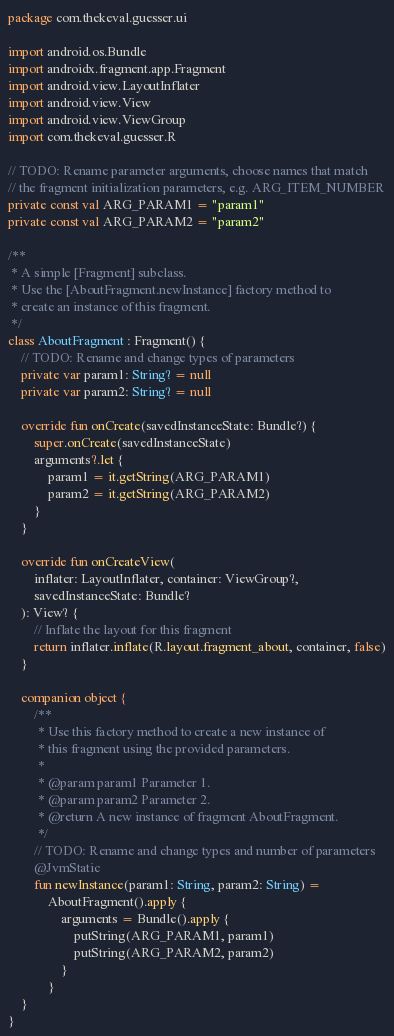Convert code to text. <code><loc_0><loc_0><loc_500><loc_500><_Kotlin_>package com.thekeval.guesser.ui

import android.os.Bundle
import androidx.fragment.app.Fragment
import android.view.LayoutInflater
import android.view.View
import android.view.ViewGroup
import com.thekeval.guesser.R

// TODO: Rename parameter arguments, choose names that match
// the fragment initialization parameters, e.g. ARG_ITEM_NUMBER
private const val ARG_PARAM1 = "param1"
private const val ARG_PARAM2 = "param2"

/**
 * A simple [Fragment] subclass.
 * Use the [AboutFragment.newInstance] factory method to
 * create an instance of this fragment.
 */
class AboutFragment : Fragment() {
    // TODO: Rename and change types of parameters
    private var param1: String? = null
    private var param2: String? = null

    override fun onCreate(savedInstanceState: Bundle?) {
        super.onCreate(savedInstanceState)
        arguments?.let {
            param1 = it.getString(ARG_PARAM1)
            param2 = it.getString(ARG_PARAM2)
        }
    }

    override fun onCreateView(
        inflater: LayoutInflater, container: ViewGroup?,
        savedInstanceState: Bundle?
    ): View? {
        // Inflate the layout for this fragment
        return inflater.inflate(R.layout.fragment_about, container, false)
    }

    companion object {
        /**
         * Use this factory method to create a new instance of
         * this fragment using the provided parameters.
         *
         * @param param1 Parameter 1.
         * @param param2 Parameter 2.
         * @return A new instance of fragment AboutFragment.
         */
        // TODO: Rename and change types and number of parameters
        @JvmStatic
        fun newInstance(param1: String, param2: String) =
            AboutFragment().apply {
                arguments = Bundle().apply {
                    putString(ARG_PARAM1, param1)
                    putString(ARG_PARAM2, param2)
                }
            }
    }
}</code> 